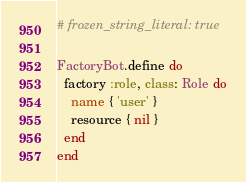<code> <loc_0><loc_0><loc_500><loc_500><_Ruby_># frozen_string_literal: true

FactoryBot.define do
  factory :role, class: Role do
    name { 'user' }
    resource { nil }
  end
end
</code> 